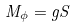<formula> <loc_0><loc_0><loc_500><loc_500>M _ { \phi } = g S</formula> 